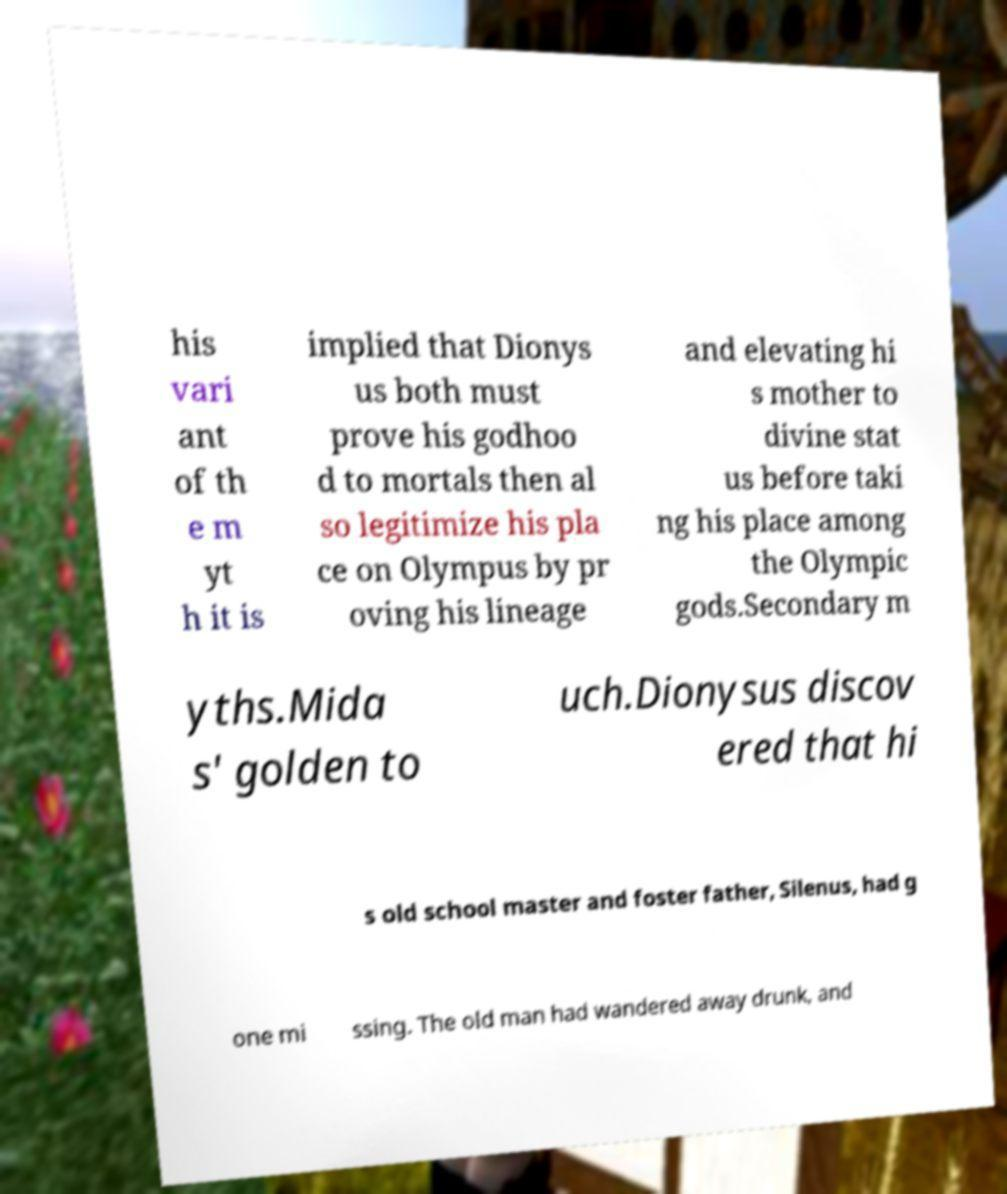I need the written content from this picture converted into text. Can you do that? his vari ant of th e m yt h it is implied that Dionys us both must prove his godhoo d to mortals then al so legitimize his pla ce on Olympus by pr oving his lineage and elevating hi s mother to divine stat us before taki ng his place among the Olympic gods.Secondary m yths.Mida s' golden to uch.Dionysus discov ered that hi s old school master and foster father, Silenus, had g one mi ssing. The old man had wandered away drunk, and 